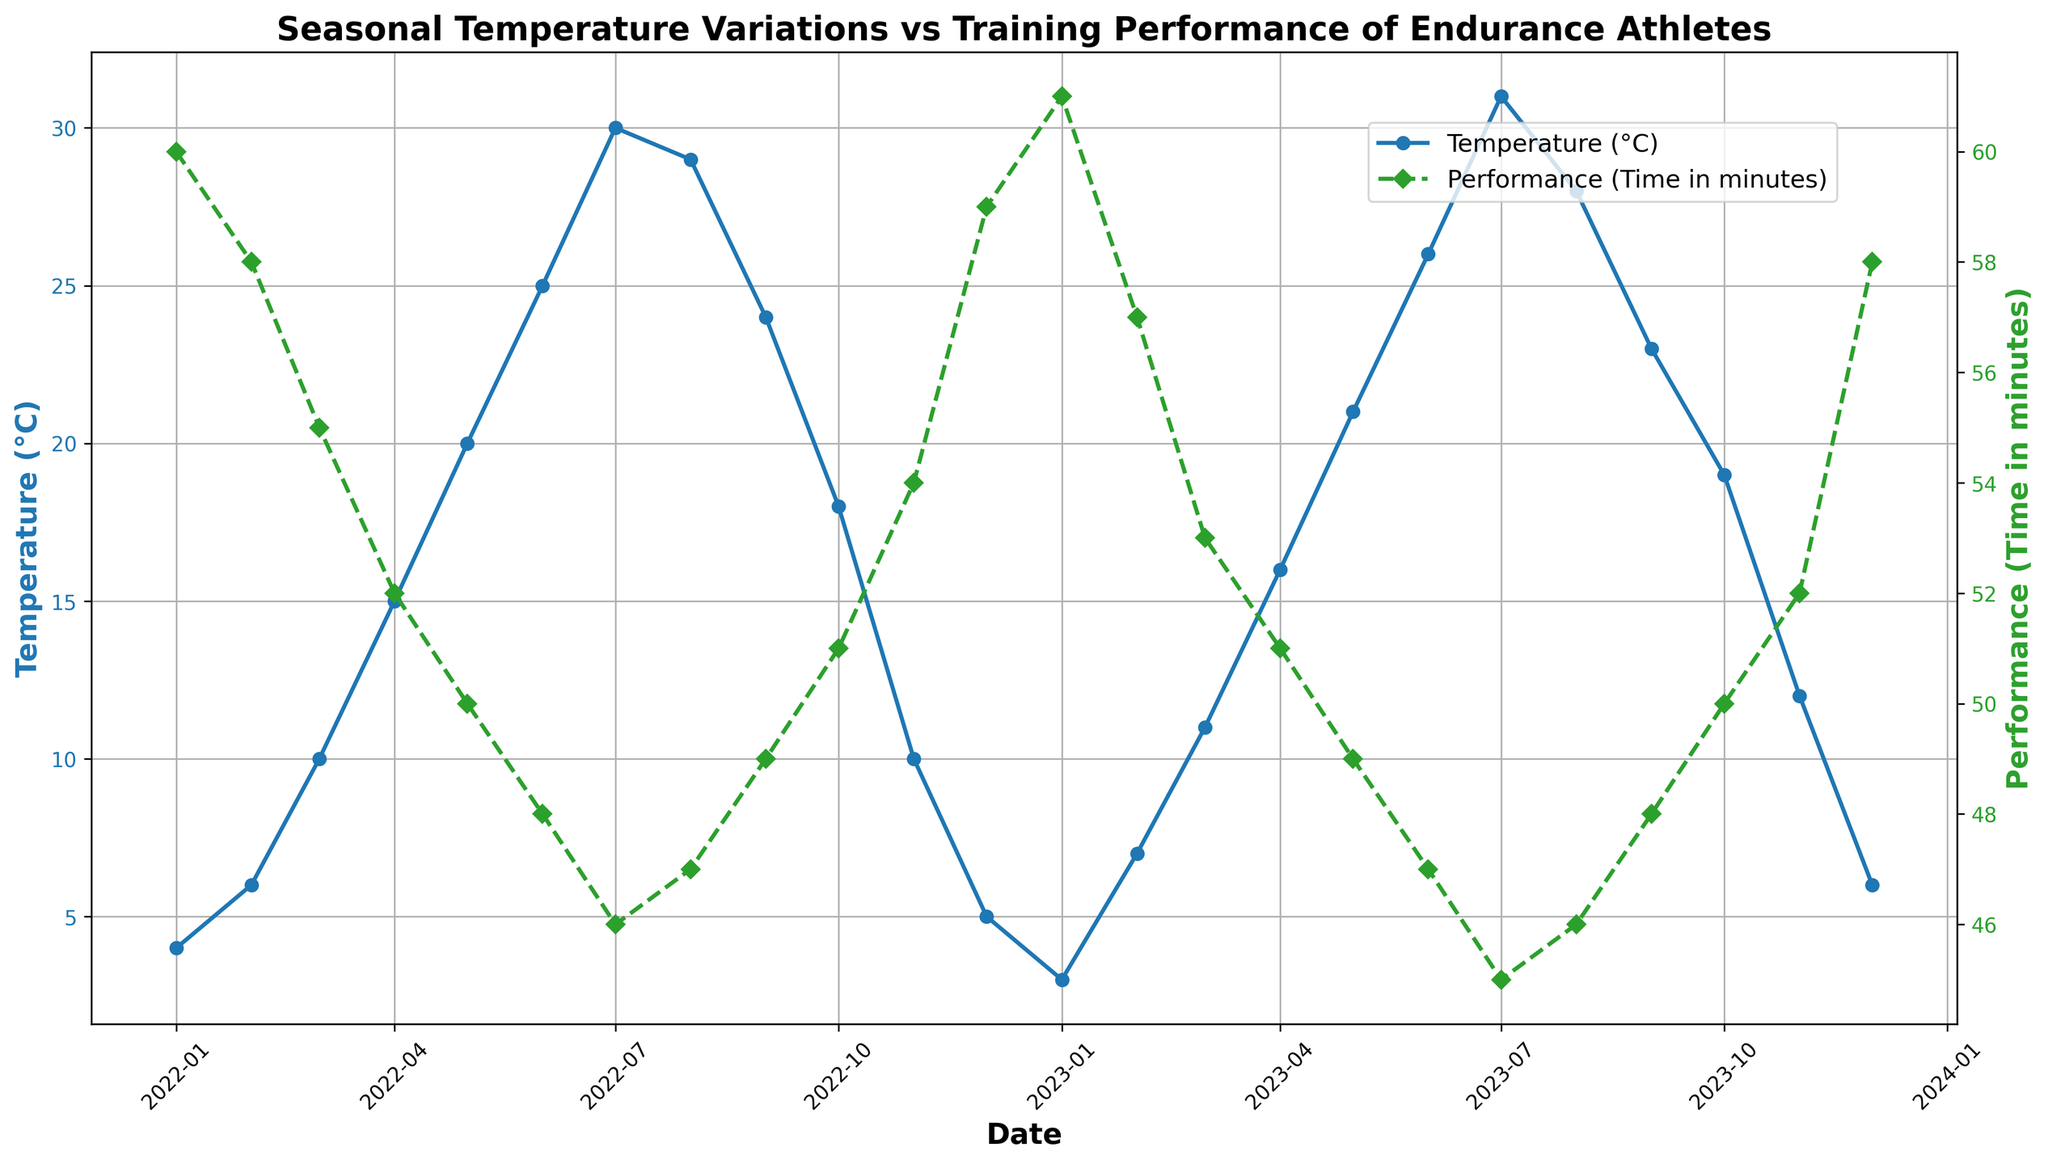What is the temperature on July 1, 2023? The chart indicates that the temperature is marked with a blue line and circle markers. Locate July 1, 2023, on the x-axis, then trace the corresponding point on the blue line to find the temperature.
Answer: 31°C Which month shows the highest temperature? By visually inspecting the blue line on the plot, identify the peak point. The highest temperature occurs where the blue line reaches its maximum. This peak is in July.
Answer: July What is the performance time in minutes for December 1, 2023? The green dashed line with diamond markers represents performance times. Locate December 1, 2023, on the x-axis and trace the corresponding point on the green line to determine the performance time.
Answer: 58 minutes How does the temperature on April 1, 2023 compare to the temperature on April 1, 2022? Identify the temperatures for both dates on the blue line. The temperature on April 1, 2022 is 15°C, and on April 1, 2023 it is 16°C. Comparing these, the temperature in 2023 is higher.
Answer: 1°C higher in 2023 What is the general trend in performance times as temperatures increase from January to July? Observe the green line trend from January to July. As the blue temperature line increases, the green performance time line descends, indicating improving performance times (decreasing minutes).
Answer: Performance times generally improve Calculate the average temperature for the months of June across both years. The temperatures for June in 2022 and 2023 are 25°C and 26°C, respectively. The average is calculated as (25 + 26) / 2.
Answer: 25.5°C By how many minutes did the performance time improve from January 1, 2022, to January 1, 2023? The performance time for January 1, 2022, is 60 minutes, and for January 1, 2023, it is 61 minutes. The difference is 61 - 60.
Answer: 1 minute decrease What visual indicator differentiates the temperature line from the performance line? The temperature line is a solid blue line with circular markers, while the performance line is a dashed green line with diamond markers.
Answer: Color and line style Which month experiences a drop in temperature compared to the previous month in both years? Examine the blue line for any downward trends. For both years, August to September marks a drop in temperature.
Answer: September 